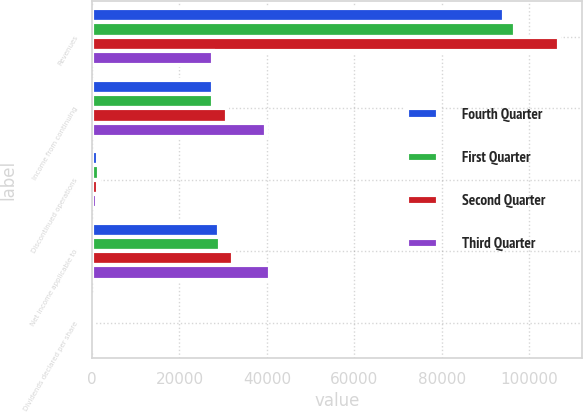Convert chart. <chart><loc_0><loc_0><loc_500><loc_500><stacked_bar_chart><ecel><fcel>Revenues<fcel>Income from continuing<fcel>Discontinued operations<fcel>Net income applicable to<fcel>Dividends declared per share<nl><fcel>Fourth Quarter<fcel>94324<fcel>27687<fcel>1447<fcel>29134<fcel>0.4<nl><fcel>First Quarter<fcel>96736<fcel>27607<fcel>1651<fcel>29258<fcel>0.4<nl><fcel>Second Quarter<fcel>106855<fcel>30954<fcel>1287<fcel>32241<fcel>0.4<nl><fcel>Third Quarter<fcel>27687<fcel>39716<fcel>1081<fcel>40797<fcel>0.4<nl></chart> 